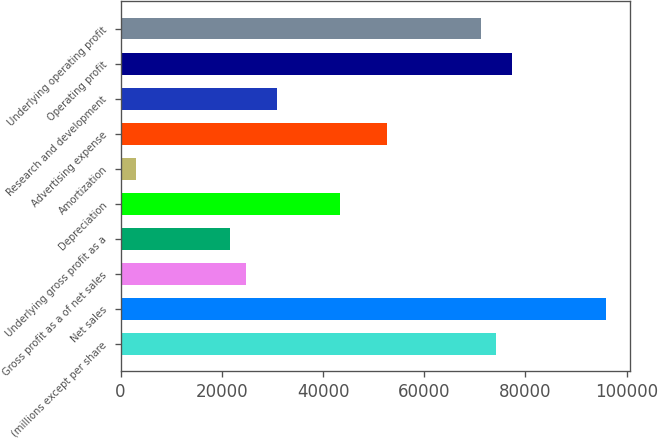Convert chart. <chart><loc_0><loc_0><loc_500><loc_500><bar_chart><fcel>(millions except per share<fcel>Net sales<fcel>Gross profit as a of net sales<fcel>Underlying gross profit as a<fcel>Depreciation<fcel>Amortization<fcel>Advertising expense<fcel>Research and development<fcel>Operating profit<fcel>Underlying operating profit<nl><fcel>74275.7<fcel>95939<fcel>24759.5<fcel>21664.8<fcel>43328.1<fcel>3096.19<fcel>52612.3<fcel>30949<fcel>77370.4<fcel>71180.9<nl></chart> 